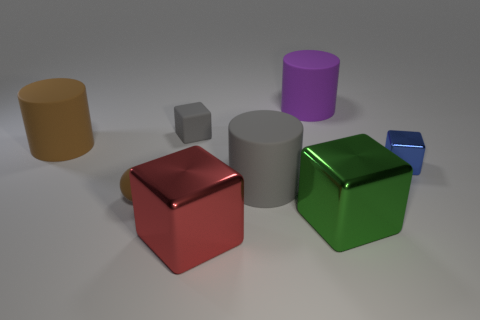Subtract all gray cubes. How many cubes are left? 3 Subtract all small metallic cubes. How many cubes are left? 3 Add 1 tiny brown rubber objects. How many objects exist? 9 Subtract all yellow cubes. Subtract all blue cylinders. How many cubes are left? 4 Subtract all balls. How many objects are left? 7 Subtract all green shiny things. Subtract all blue metallic objects. How many objects are left? 6 Add 1 big gray matte cylinders. How many big gray matte cylinders are left? 2 Add 1 small blue metal things. How many small blue metal things exist? 2 Subtract 0 blue spheres. How many objects are left? 8 